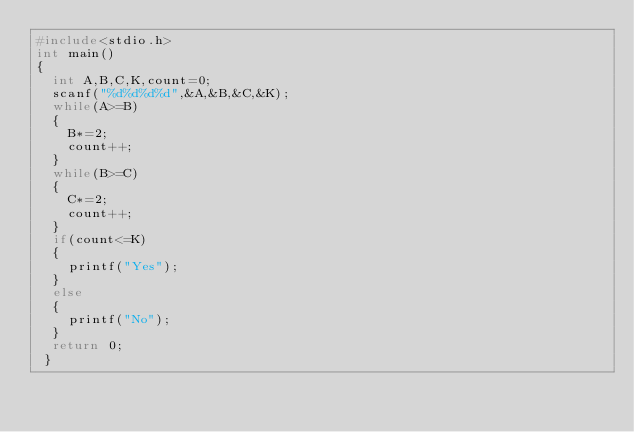<code> <loc_0><loc_0><loc_500><loc_500><_C_>#include<stdio.h>
int main()
{
	int A,B,C,K,count=0;
	scanf("%d%d%d%d",&A,&B,&C,&K);
	while(A>=B)
	{
		B*=2;
		count++;
	}
	while(B>=C)
	{
		C*=2;
		count++;
	}
	if(count<=K)
	{
		printf("Yes");
	}
	else
	{
		printf("No");
	}
	return 0;
 } </code> 